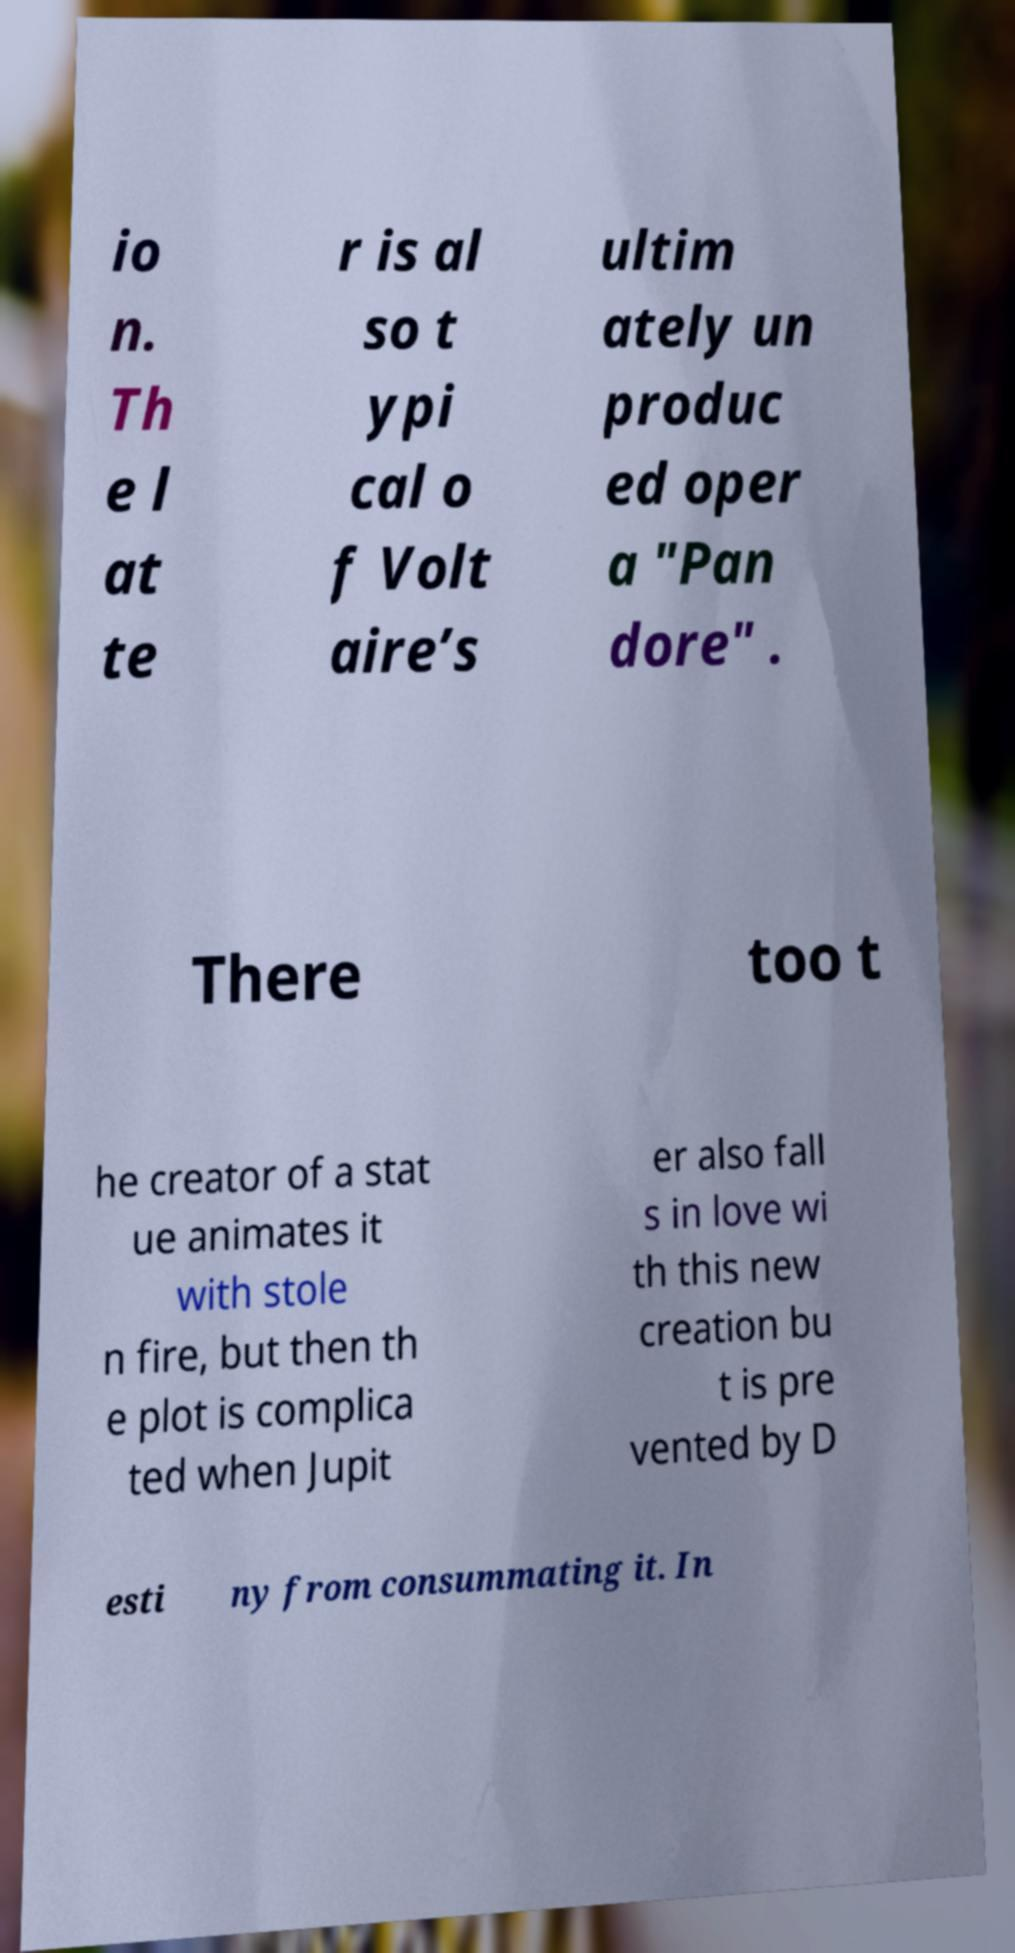Can you accurately transcribe the text from the provided image for me? io n. Th e l at te r is al so t ypi cal o f Volt aire’s ultim ately un produc ed oper a "Pan dore" . There too t he creator of a stat ue animates it with stole n fire, but then th e plot is complica ted when Jupit er also fall s in love wi th this new creation bu t is pre vented by D esti ny from consummating it. In 